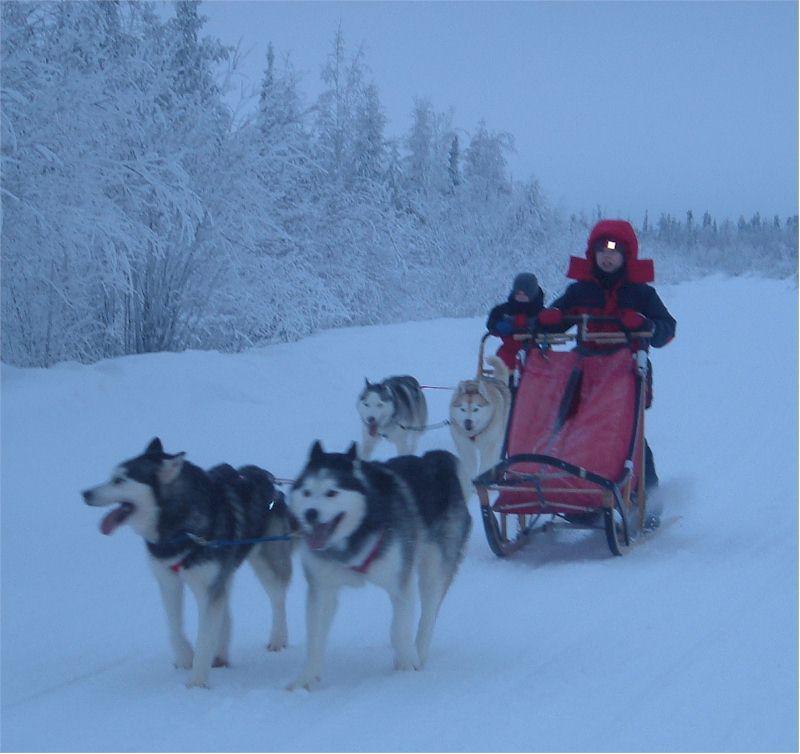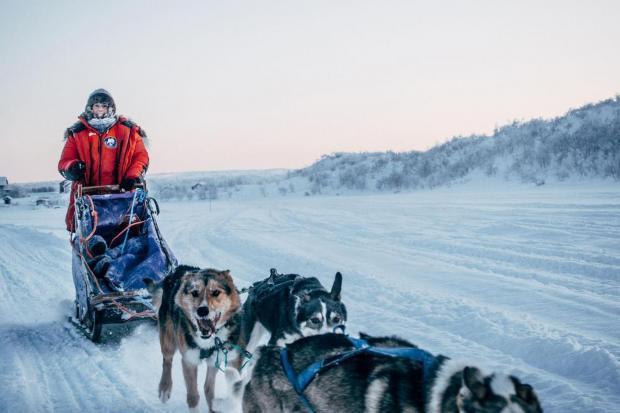The first image is the image on the left, the second image is the image on the right. Assess this claim about the two images: "A figure in red outerwear stands behind a rightward-angled sled with no passenger, pulled by at least one dog figure.". Correct or not? Answer yes or no. Yes. The first image is the image on the left, the second image is the image on the right. Analyze the images presented: Is the assertion "The person on the sled in the image on the right is wearing a red jacket." valid? Answer yes or no. Yes. 